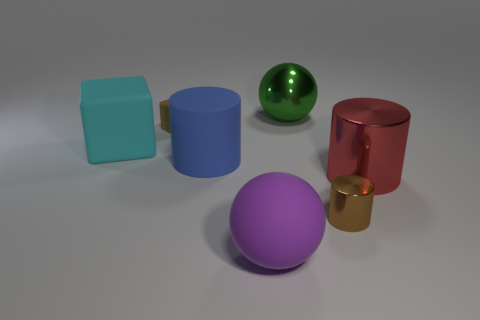Subtract all matte cylinders. How many cylinders are left? 2 Add 3 small red rubber cubes. How many objects exist? 10 Subtract all purple balls. How many balls are left? 1 Subtract 0 red spheres. How many objects are left? 7 Subtract all cylinders. How many objects are left? 4 Subtract 1 cylinders. How many cylinders are left? 2 Subtract all yellow blocks. Subtract all yellow cylinders. How many blocks are left? 2 Subtract all red cylinders. Subtract all brown blocks. How many objects are left? 5 Add 7 shiny balls. How many shiny balls are left? 8 Add 1 large green metal things. How many large green metal things exist? 2 